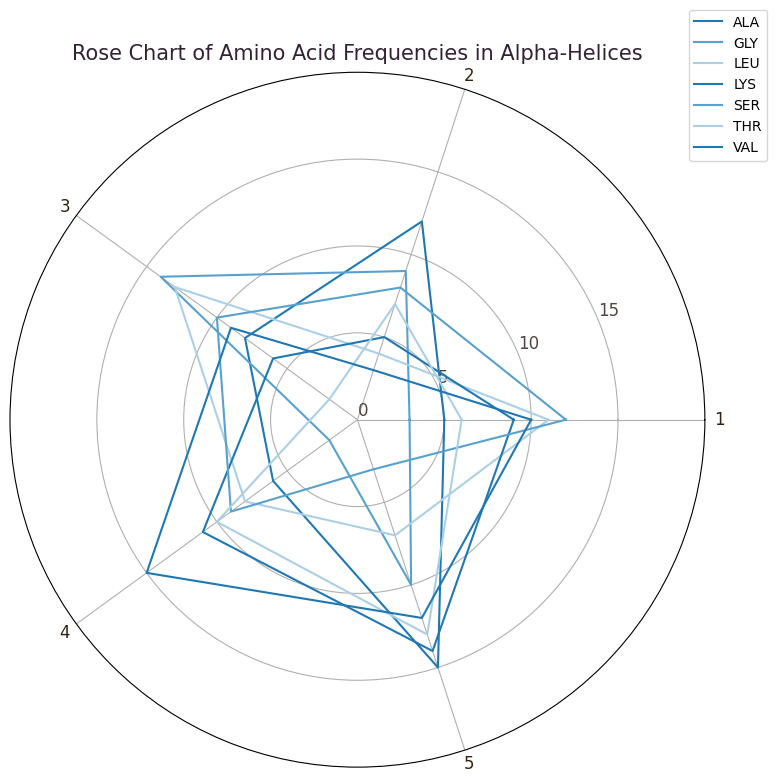Which amino acid has the highest frequency at position 5? Look at the radial values at position 5 and identify the highest value for any amino acid. ALA has a frequency of 15 at position 5, which is the highest.
Answer: ALA Which position has the highest average frequency for GLY? Add the frequencies of GLY at all positions and divide by the number of positions (1, 2, 3, 4, 5). Average = (3+9+14+2+10)/5 = 7.6.
Answer: 3 Which amino acid shows a peak frequency at position 4? Check which amino acid has the highest frequency value at position 4 on the radial chart. VAL has the highest frequency of 15 at position 4.
Answer: VAL Compare the frequencies of LEU and SER at position 1. Which one is higher? Look at position 1 and compare the frequencies of LEU and SER. LEU has a frequency of 11, while SER has a frequency of 12.
Answer: SER Which amino acid has the most consistent frequency across all positions? Identify the amino acid whose frequencies have the least variation (smallest range or standard deviation). SER frequencies (12, 8, 10, 9, 3) show relatively small variation.
Answer: SER Sum the frequencies of LYS at positions 2 and 4. What is the total? Add the frequencies of LYS at position 2 and position 4. The frequencies are 5 and 11. Total = 5 + 11 = 16.
Answer: 16 Does any amino acid have exactly the same frequency at two different positions? If so, name one. Check each amino acid to see if there are two positions with the same frequency. LYS has a frequency of 6 at both positions 3 and 1.
Answer: LYS Which amino acid's frequency increases the most between positions 2 and 5? Find the amino acid with the largest positive difference between frequencies at positions 2 and 5. LYS increases from 5 at position 2 to 14 at position 5. Δ = 14 - 5 = 9.
Answer: LYS What's the difference in frequencies of VAL at positions 3 and 5? Subtract the frequency of VAL at position 3 from its frequency at position 5. The frequencies are 9 and 12 respectively. Difference = 12 - 9 = 3.
Answer: 3 